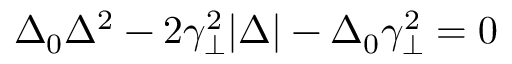<formula> <loc_0><loc_0><loc_500><loc_500>\Delta _ { 0 } \Delta ^ { 2 } - 2 \gamma _ { \perp } ^ { 2 } | \Delta | - \Delta _ { 0 } \gamma _ { \perp } ^ { 2 } = 0</formula> 